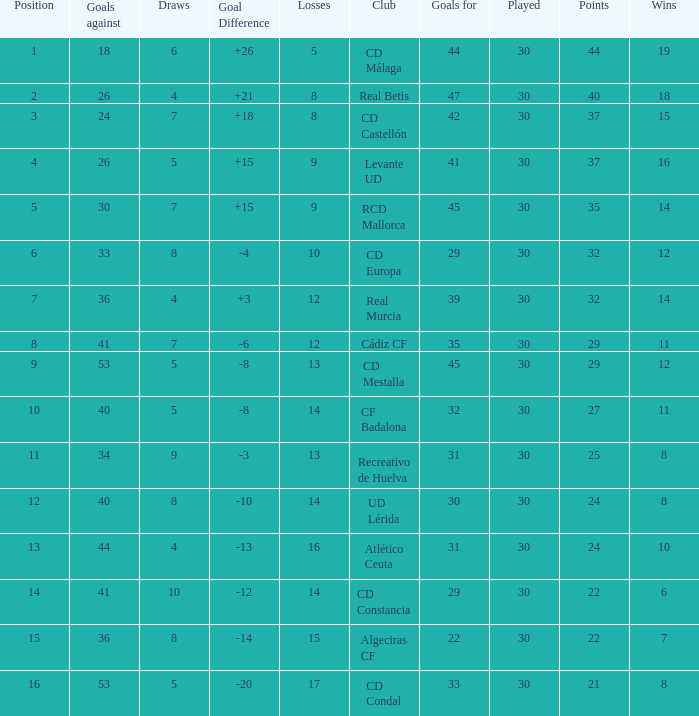What is the number of draws when played is smaller than 30? 0.0. 